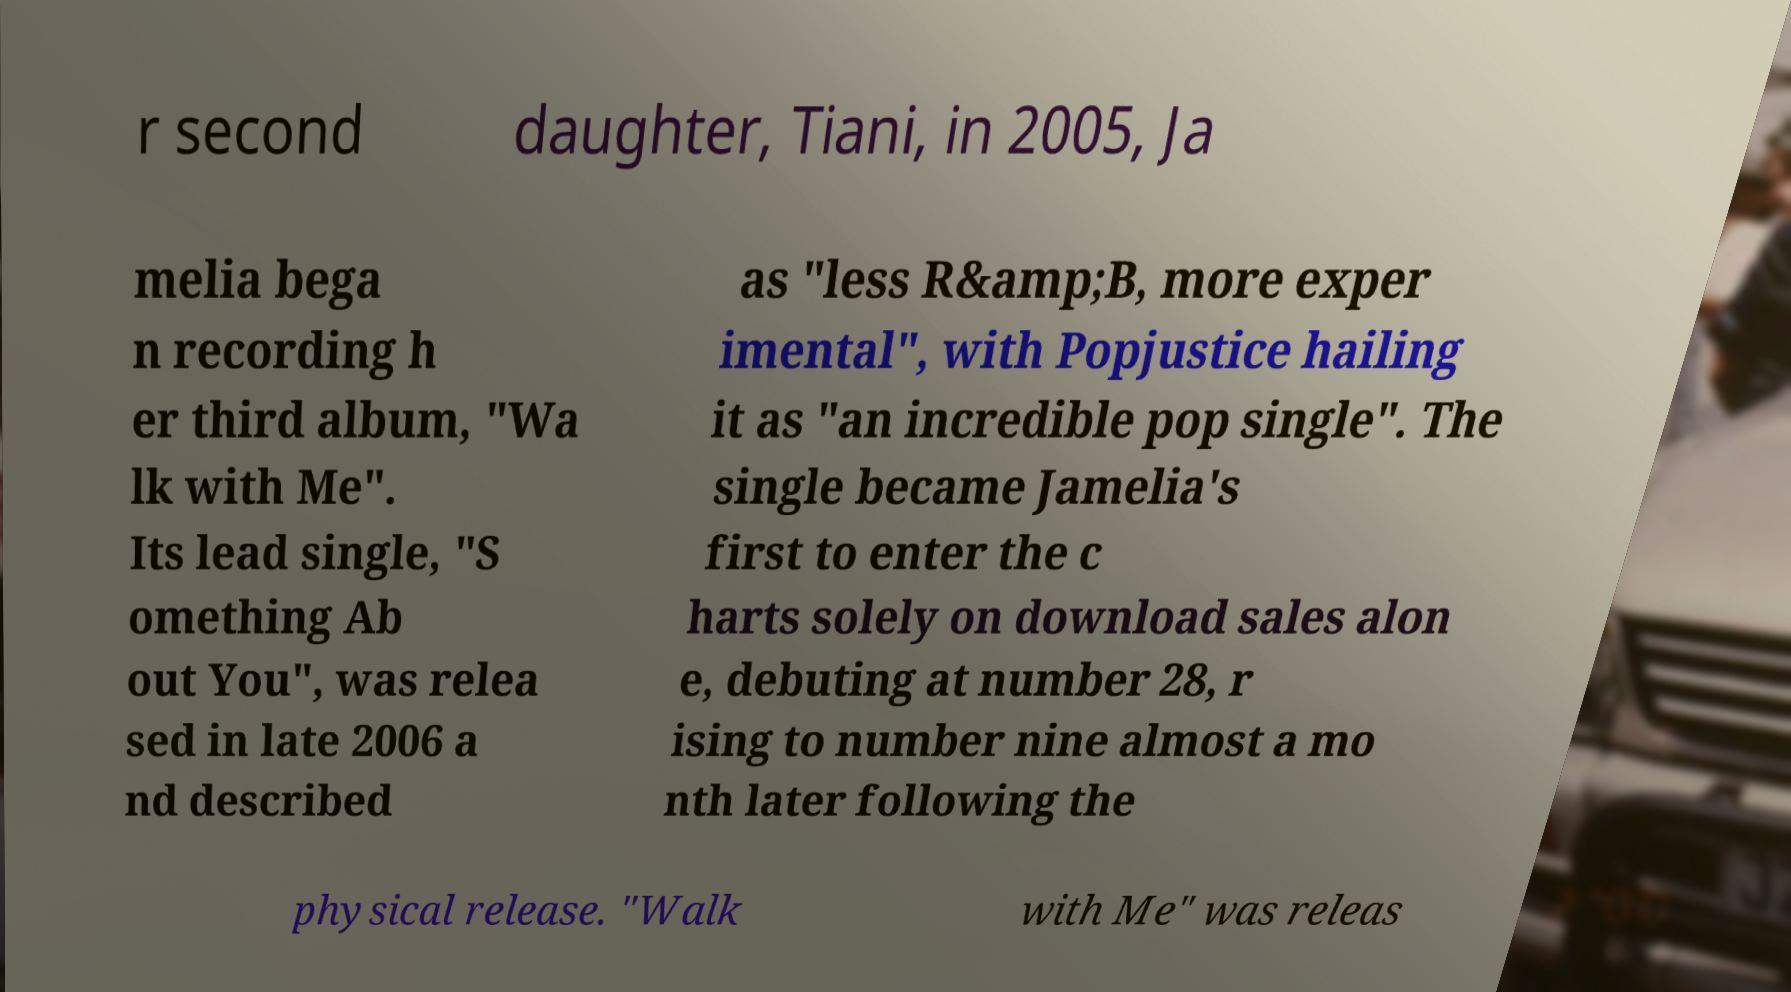Please read and relay the text visible in this image. What does it say? r second daughter, Tiani, in 2005, Ja melia bega n recording h er third album, "Wa lk with Me". Its lead single, "S omething Ab out You", was relea sed in late 2006 a nd described as "less R&amp;B, more exper imental", with Popjustice hailing it as "an incredible pop single". The single became Jamelia's first to enter the c harts solely on download sales alon e, debuting at number 28, r ising to number nine almost a mo nth later following the physical release. "Walk with Me" was releas 